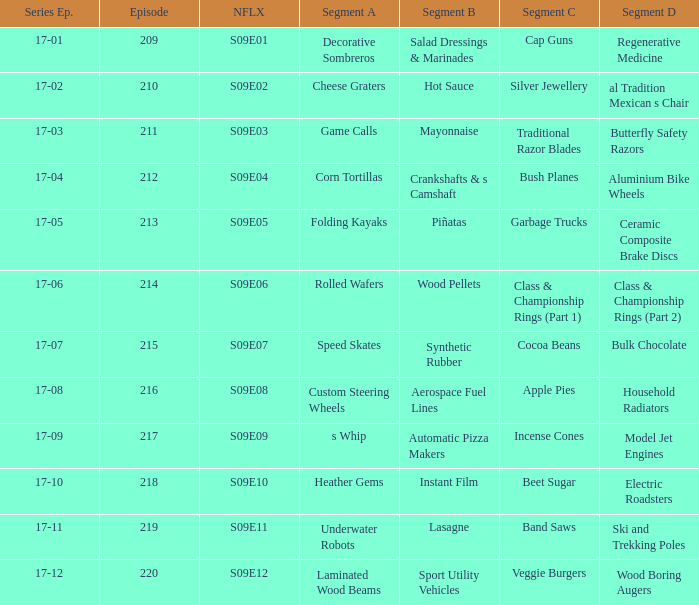For the shows featuring beet sugar, what was on before that Instant Film. 